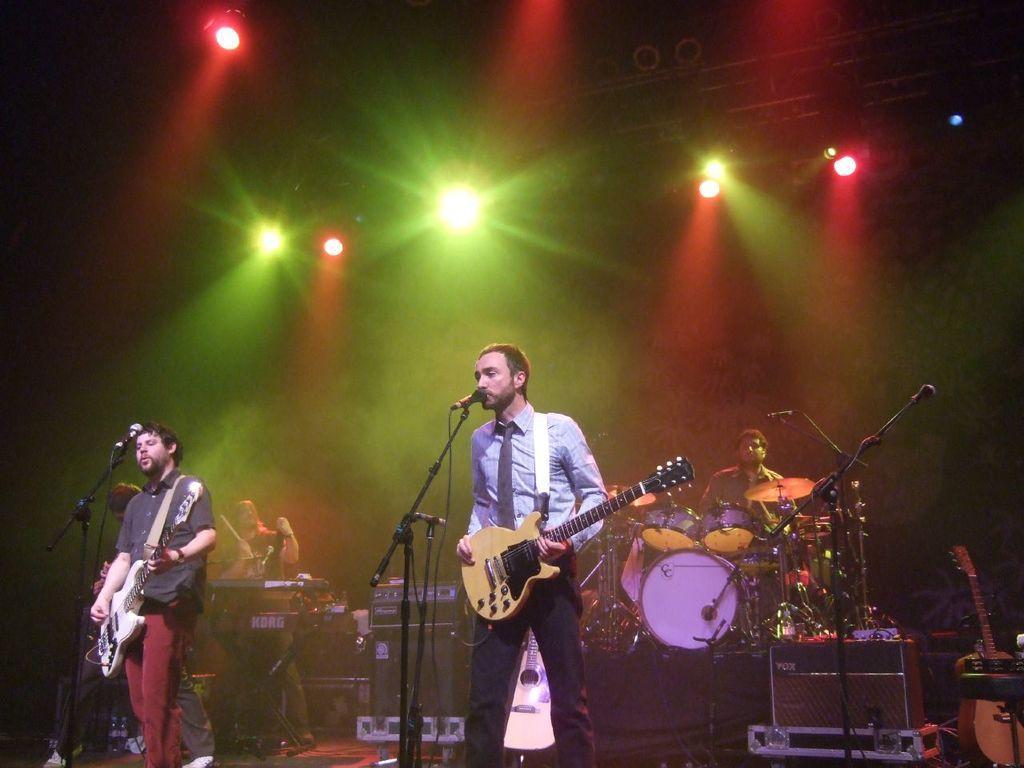Please provide a concise description of this image. Here we can see that a person is standing on the floor and singing an holding a guitar in his hands, and at beside a person is standing and playing the guitar and in front her is microphone, and at back there are musical drums, and at above her are lights. 